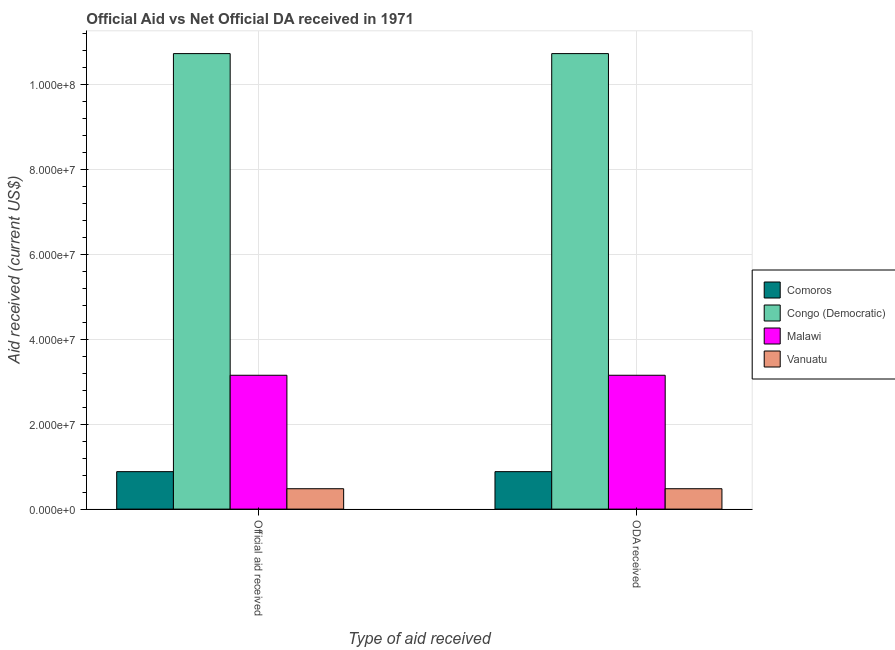How many groups of bars are there?
Ensure brevity in your answer.  2. Are the number of bars per tick equal to the number of legend labels?
Offer a very short reply. Yes. How many bars are there on the 1st tick from the left?
Keep it short and to the point. 4. What is the label of the 2nd group of bars from the left?
Your answer should be very brief. ODA received. What is the official aid received in Malawi?
Offer a very short reply. 3.15e+07. Across all countries, what is the maximum oda received?
Your answer should be very brief. 1.07e+08. Across all countries, what is the minimum official aid received?
Give a very brief answer. 4.80e+06. In which country was the oda received maximum?
Your answer should be very brief. Congo (Democratic). In which country was the oda received minimum?
Provide a succinct answer. Vanuatu. What is the total official aid received in the graph?
Your answer should be compact. 1.52e+08. What is the difference between the oda received in Vanuatu and that in Congo (Democratic)?
Provide a short and direct response. -1.02e+08. What is the difference between the official aid received in Congo (Democratic) and the oda received in Vanuatu?
Your answer should be very brief. 1.02e+08. What is the average oda received per country?
Give a very brief answer. 3.81e+07. What is the ratio of the official aid received in Vanuatu to that in Congo (Democratic)?
Offer a very short reply. 0.04. Is the oda received in Malawi less than that in Congo (Democratic)?
Your response must be concise. Yes. What does the 4th bar from the left in Official aid received represents?
Provide a succinct answer. Vanuatu. What does the 4th bar from the right in ODA received represents?
Ensure brevity in your answer.  Comoros. How many bars are there?
Offer a terse response. 8. Are all the bars in the graph horizontal?
Offer a terse response. No. Does the graph contain any zero values?
Your answer should be very brief. No. Where does the legend appear in the graph?
Offer a terse response. Center right. How many legend labels are there?
Provide a short and direct response. 4. What is the title of the graph?
Offer a very short reply. Official Aid vs Net Official DA received in 1971 . Does "Ukraine" appear as one of the legend labels in the graph?
Offer a terse response. No. What is the label or title of the X-axis?
Offer a very short reply. Type of aid received. What is the label or title of the Y-axis?
Ensure brevity in your answer.  Aid received (current US$). What is the Aid received (current US$) in Comoros in Official aid received?
Your answer should be very brief. 8.82e+06. What is the Aid received (current US$) in Congo (Democratic) in Official aid received?
Your response must be concise. 1.07e+08. What is the Aid received (current US$) in Malawi in Official aid received?
Provide a succinct answer. 3.15e+07. What is the Aid received (current US$) of Vanuatu in Official aid received?
Provide a short and direct response. 4.80e+06. What is the Aid received (current US$) in Comoros in ODA received?
Give a very brief answer. 8.82e+06. What is the Aid received (current US$) of Congo (Democratic) in ODA received?
Your answer should be compact. 1.07e+08. What is the Aid received (current US$) of Malawi in ODA received?
Provide a short and direct response. 3.15e+07. What is the Aid received (current US$) of Vanuatu in ODA received?
Keep it short and to the point. 4.80e+06. Across all Type of aid received, what is the maximum Aid received (current US$) in Comoros?
Make the answer very short. 8.82e+06. Across all Type of aid received, what is the maximum Aid received (current US$) in Congo (Democratic)?
Keep it short and to the point. 1.07e+08. Across all Type of aid received, what is the maximum Aid received (current US$) in Malawi?
Provide a succinct answer. 3.15e+07. Across all Type of aid received, what is the maximum Aid received (current US$) of Vanuatu?
Make the answer very short. 4.80e+06. Across all Type of aid received, what is the minimum Aid received (current US$) in Comoros?
Your answer should be compact. 8.82e+06. Across all Type of aid received, what is the minimum Aid received (current US$) in Congo (Democratic)?
Keep it short and to the point. 1.07e+08. Across all Type of aid received, what is the minimum Aid received (current US$) in Malawi?
Make the answer very short. 3.15e+07. Across all Type of aid received, what is the minimum Aid received (current US$) of Vanuatu?
Make the answer very short. 4.80e+06. What is the total Aid received (current US$) in Comoros in the graph?
Offer a terse response. 1.76e+07. What is the total Aid received (current US$) of Congo (Democratic) in the graph?
Your answer should be very brief. 2.15e+08. What is the total Aid received (current US$) in Malawi in the graph?
Make the answer very short. 6.30e+07. What is the total Aid received (current US$) in Vanuatu in the graph?
Make the answer very short. 9.60e+06. What is the difference between the Aid received (current US$) of Comoros in Official aid received and that in ODA received?
Keep it short and to the point. 0. What is the difference between the Aid received (current US$) in Congo (Democratic) in Official aid received and that in ODA received?
Provide a succinct answer. 0. What is the difference between the Aid received (current US$) of Comoros in Official aid received and the Aid received (current US$) of Congo (Democratic) in ODA received?
Keep it short and to the point. -9.84e+07. What is the difference between the Aid received (current US$) of Comoros in Official aid received and the Aid received (current US$) of Malawi in ODA received?
Your answer should be compact. -2.27e+07. What is the difference between the Aid received (current US$) of Comoros in Official aid received and the Aid received (current US$) of Vanuatu in ODA received?
Your response must be concise. 4.02e+06. What is the difference between the Aid received (current US$) in Congo (Democratic) in Official aid received and the Aid received (current US$) in Malawi in ODA received?
Ensure brevity in your answer.  7.58e+07. What is the difference between the Aid received (current US$) of Congo (Democratic) in Official aid received and the Aid received (current US$) of Vanuatu in ODA received?
Offer a terse response. 1.02e+08. What is the difference between the Aid received (current US$) in Malawi in Official aid received and the Aid received (current US$) in Vanuatu in ODA received?
Your response must be concise. 2.67e+07. What is the average Aid received (current US$) of Comoros per Type of aid received?
Ensure brevity in your answer.  8.82e+06. What is the average Aid received (current US$) of Congo (Democratic) per Type of aid received?
Ensure brevity in your answer.  1.07e+08. What is the average Aid received (current US$) in Malawi per Type of aid received?
Keep it short and to the point. 3.15e+07. What is the average Aid received (current US$) in Vanuatu per Type of aid received?
Provide a succinct answer. 4.80e+06. What is the difference between the Aid received (current US$) in Comoros and Aid received (current US$) in Congo (Democratic) in Official aid received?
Offer a terse response. -9.84e+07. What is the difference between the Aid received (current US$) of Comoros and Aid received (current US$) of Malawi in Official aid received?
Offer a terse response. -2.27e+07. What is the difference between the Aid received (current US$) of Comoros and Aid received (current US$) of Vanuatu in Official aid received?
Ensure brevity in your answer.  4.02e+06. What is the difference between the Aid received (current US$) of Congo (Democratic) and Aid received (current US$) of Malawi in Official aid received?
Your answer should be compact. 7.58e+07. What is the difference between the Aid received (current US$) of Congo (Democratic) and Aid received (current US$) of Vanuatu in Official aid received?
Make the answer very short. 1.02e+08. What is the difference between the Aid received (current US$) of Malawi and Aid received (current US$) of Vanuatu in Official aid received?
Keep it short and to the point. 2.67e+07. What is the difference between the Aid received (current US$) in Comoros and Aid received (current US$) in Congo (Democratic) in ODA received?
Your response must be concise. -9.84e+07. What is the difference between the Aid received (current US$) of Comoros and Aid received (current US$) of Malawi in ODA received?
Provide a short and direct response. -2.27e+07. What is the difference between the Aid received (current US$) in Comoros and Aid received (current US$) in Vanuatu in ODA received?
Offer a very short reply. 4.02e+06. What is the difference between the Aid received (current US$) in Congo (Democratic) and Aid received (current US$) in Malawi in ODA received?
Ensure brevity in your answer.  7.58e+07. What is the difference between the Aid received (current US$) of Congo (Democratic) and Aid received (current US$) of Vanuatu in ODA received?
Your answer should be very brief. 1.02e+08. What is the difference between the Aid received (current US$) in Malawi and Aid received (current US$) in Vanuatu in ODA received?
Your answer should be compact. 2.67e+07. What is the ratio of the Aid received (current US$) in Comoros in Official aid received to that in ODA received?
Your answer should be compact. 1. What is the ratio of the Aid received (current US$) in Vanuatu in Official aid received to that in ODA received?
Your response must be concise. 1. What is the difference between the highest and the second highest Aid received (current US$) in Congo (Democratic)?
Ensure brevity in your answer.  0. What is the difference between the highest and the second highest Aid received (current US$) in Malawi?
Give a very brief answer. 0. What is the difference between the highest and the second highest Aid received (current US$) in Vanuatu?
Keep it short and to the point. 0. What is the difference between the highest and the lowest Aid received (current US$) in Congo (Democratic)?
Keep it short and to the point. 0. 